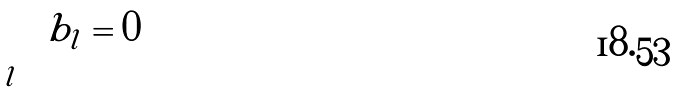Convert formula to latex. <formula><loc_0><loc_0><loc_500><loc_500>\sum _ { l } b _ { l } = 0</formula> 